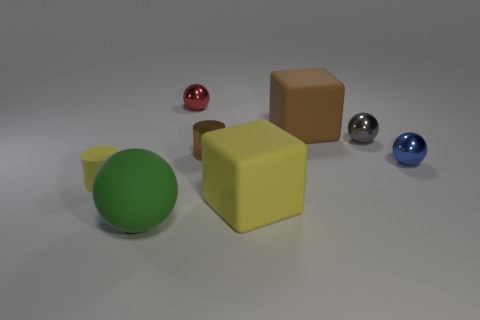Subtract all large balls. How many balls are left? 3 Subtract all yellow cylinders. How many cylinders are left? 1 Subtract all cylinders. How many objects are left? 6 Add 1 big purple cylinders. How many objects exist? 9 Subtract all blue balls. Subtract all tiny shiny balls. How many objects are left? 4 Add 8 big yellow objects. How many big yellow objects are left? 9 Add 7 tiny gray shiny things. How many tiny gray shiny things exist? 8 Subtract 0 purple cylinders. How many objects are left? 8 Subtract 1 blocks. How many blocks are left? 1 Subtract all gray balls. Subtract all red cubes. How many balls are left? 3 